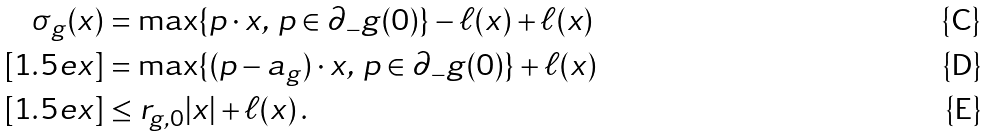<formula> <loc_0><loc_0><loc_500><loc_500>\sigma _ { g } ( x ) & = \max \{ p \cdot x , \, p \in \partial _ { - } g ( 0 ) \} - \ell ( x ) + \ell ( x ) \\ [ 1 . 5 e x ] & = \max \{ ( p - a _ { g } ) \cdot x , \, p \in \partial _ { - } g ( 0 ) \} + \ell ( x ) \\ [ 1 . 5 e x ] & \leq r _ { g , 0 } | x | + \ell ( x ) \, .</formula> 